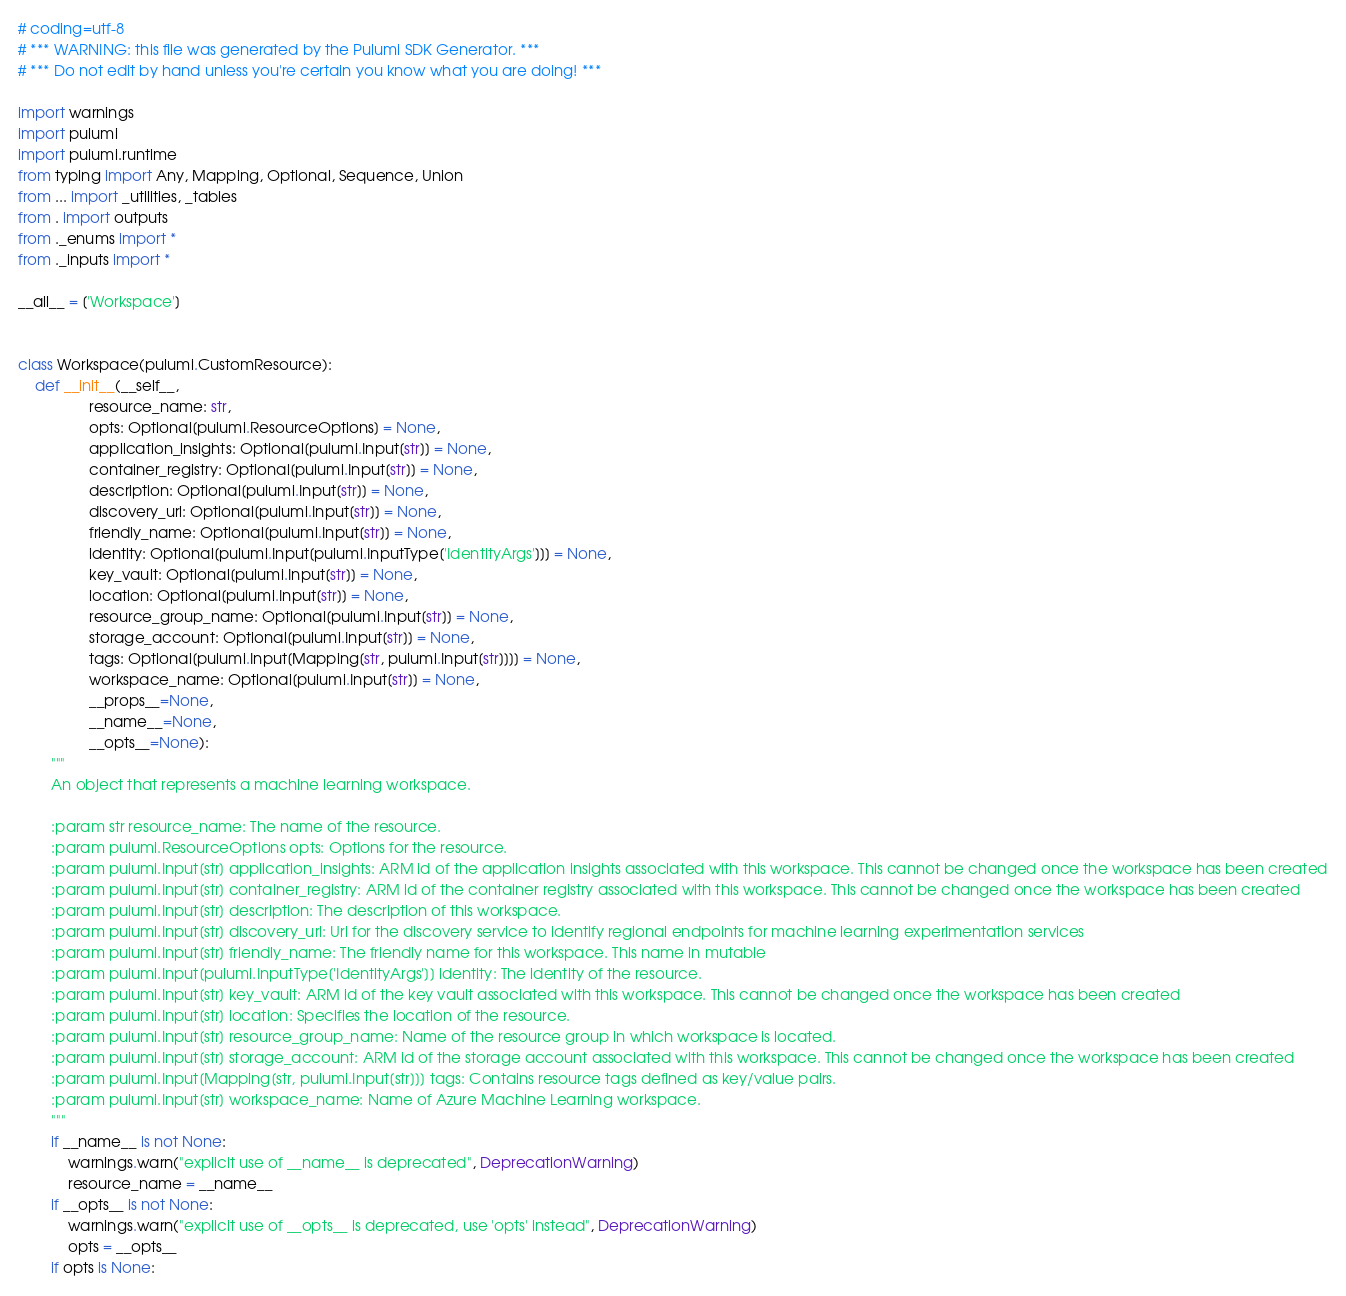<code> <loc_0><loc_0><loc_500><loc_500><_Python_># coding=utf-8
# *** WARNING: this file was generated by the Pulumi SDK Generator. ***
# *** Do not edit by hand unless you're certain you know what you are doing! ***

import warnings
import pulumi
import pulumi.runtime
from typing import Any, Mapping, Optional, Sequence, Union
from ... import _utilities, _tables
from . import outputs
from ._enums import *
from ._inputs import *

__all__ = ['Workspace']


class Workspace(pulumi.CustomResource):
    def __init__(__self__,
                 resource_name: str,
                 opts: Optional[pulumi.ResourceOptions] = None,
                 application_insights: Optional[pulumi.Input[str]] = None,
                 container_registry: Optional[pulumi.Input[str]] = None,
                 description: Optional[pulumi.Input[str]] = None,
                 discovery_url: Optional[pulumi.Input[str]] = None,
                 friendly_name: Optional[pulumi.Input[str]] = None,
                 identity: Optional[pulumi.Input[pulumi.InputType['IdentityArgs']]] = None,
                 key_vault: Optional[pulumi.Input[str]] = None,
                 location: Optional[pulumi.Input[str]] = None,
                 resource_group_name: Optional[pulumi.Input[str]] = None,
                 storage_account: Optional[pulumi.Input[str]] = None,
                 tags: Optional[pulumi.Input[Mapping[str, pulumi.Input[str]]]] = None,
                 workspace_name: Optional[pulumi.Input[str]] = None,
                 __props__=None,
                 __name__=None,
                 __opts__=None):
        """
        An object that represents a machine learning workspace.

        :param str resource_name: The name of the resource.
        :param pulumi.ResourceOptions opts: Options for the resource.
        :param pulumi.Input[str] application_insights: ARM id of the application insights associated with this workspace. This cannot be changed once the workspace has been created
        :param pulumi.Input[str] container_registry: ARM id of the container registry associated with this workspace. This cannot be changed once the workspace has been created
        :param pulumi.Input[str] description: The description of this workspace.
        :param pulumi.Input[str] discovery_url: Url for the discovery service to identify regional endpoints for machine learning experimentation services
        :param pulumi.Input[str] friendly_name: The friendly name for this workspace. This name in mutable
        :param pulumi.Input[pulumi.InputType['IdentityArgs']] identity: The identity of the resource.
        :param pulumi.Input[str] key_vault: ARM id of the key vault associated with this workspace. This cannot be changed once the workspace has been created
        :param pulumi.Input[str] location: Specifies the location of the resource.
        :param pulumi.Input[str] resource_group_name: Name of the resource group in which workspace is located.
        :param pulumi.Input[str] storage_account: ARM id of the storage account associated with this workspace. This cannot be changed once the workspace has been created
        :param pulumi.Input[Mapping[str, pulumi.Input[str]]] tags: Contains resource tags defined as key/value pairs.
        :param pulumi.Input[str] workspace_name: Name of Azure Machine Learning workspace.
        """
        if __name__ is not None:
            warnings.warn("explicit use of __name__ is deprecated", DeprecationWarning)
            resource_name = __name__
        if __opts__ is not None:
            warnings.warn("explicit use of __opts__ is deprecated, use 'opts' instead", DeprecationWarning)
            opts = __opts__
        if opts is None:</code> 